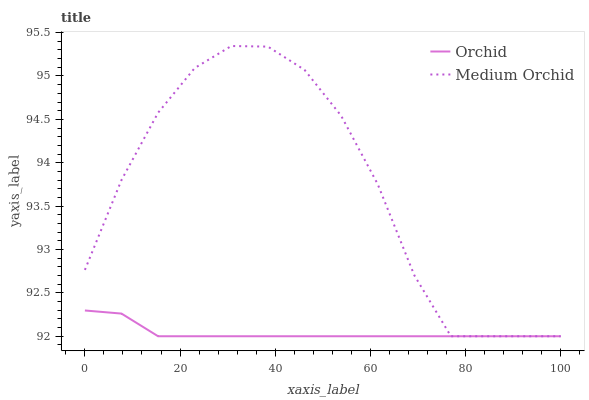Does Orchid have the minimum area under the curve?
Answer yes or no. Yes. Does Medium Orchid have the maximum area under the curve?
Answer yes or no. Yes. Does Orchid have the maximum area under the curve?
Answer yes or no. No. Is Orchid the smoothest?
Answer yes or no. Yes. Is Medium Orchid the roughest?
Answer yes or no. Yes. Is Orchid the roughest?
Answer yes or no. No. Does Medium Orchid have the highest value?
Answer yes or no. Yes. Does Orchid have the highest value?
Answer yes or no. No. 